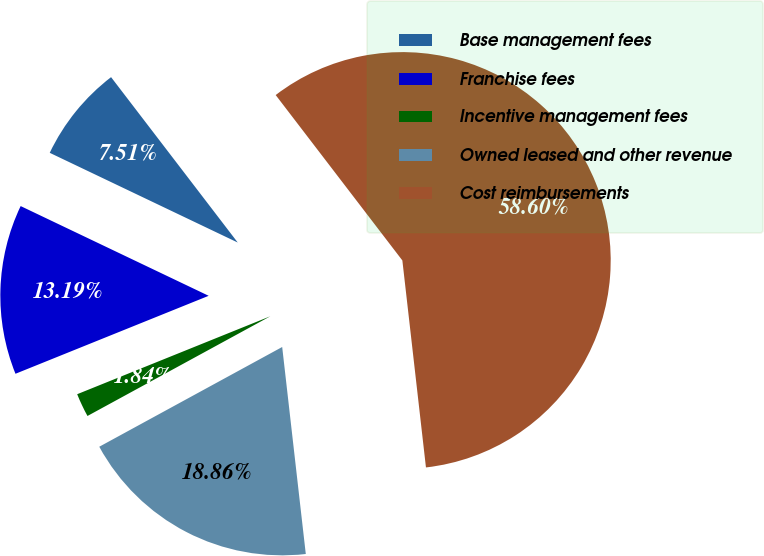Convert chart to OTSL. <chart><loc_0><loc_0><loc_500><loc_500><pie_chart><fcel>Base management fees<fcel>Franchise fees<fcel>Incentive management fees<fcel>Owned leased and other revenue<fcel>Cost reimbursements<nl><fcel>7.51%<fcel>13.19%<fcel>1.84%<fcel>18.86%<fcel>58.59%<nl></chart> 